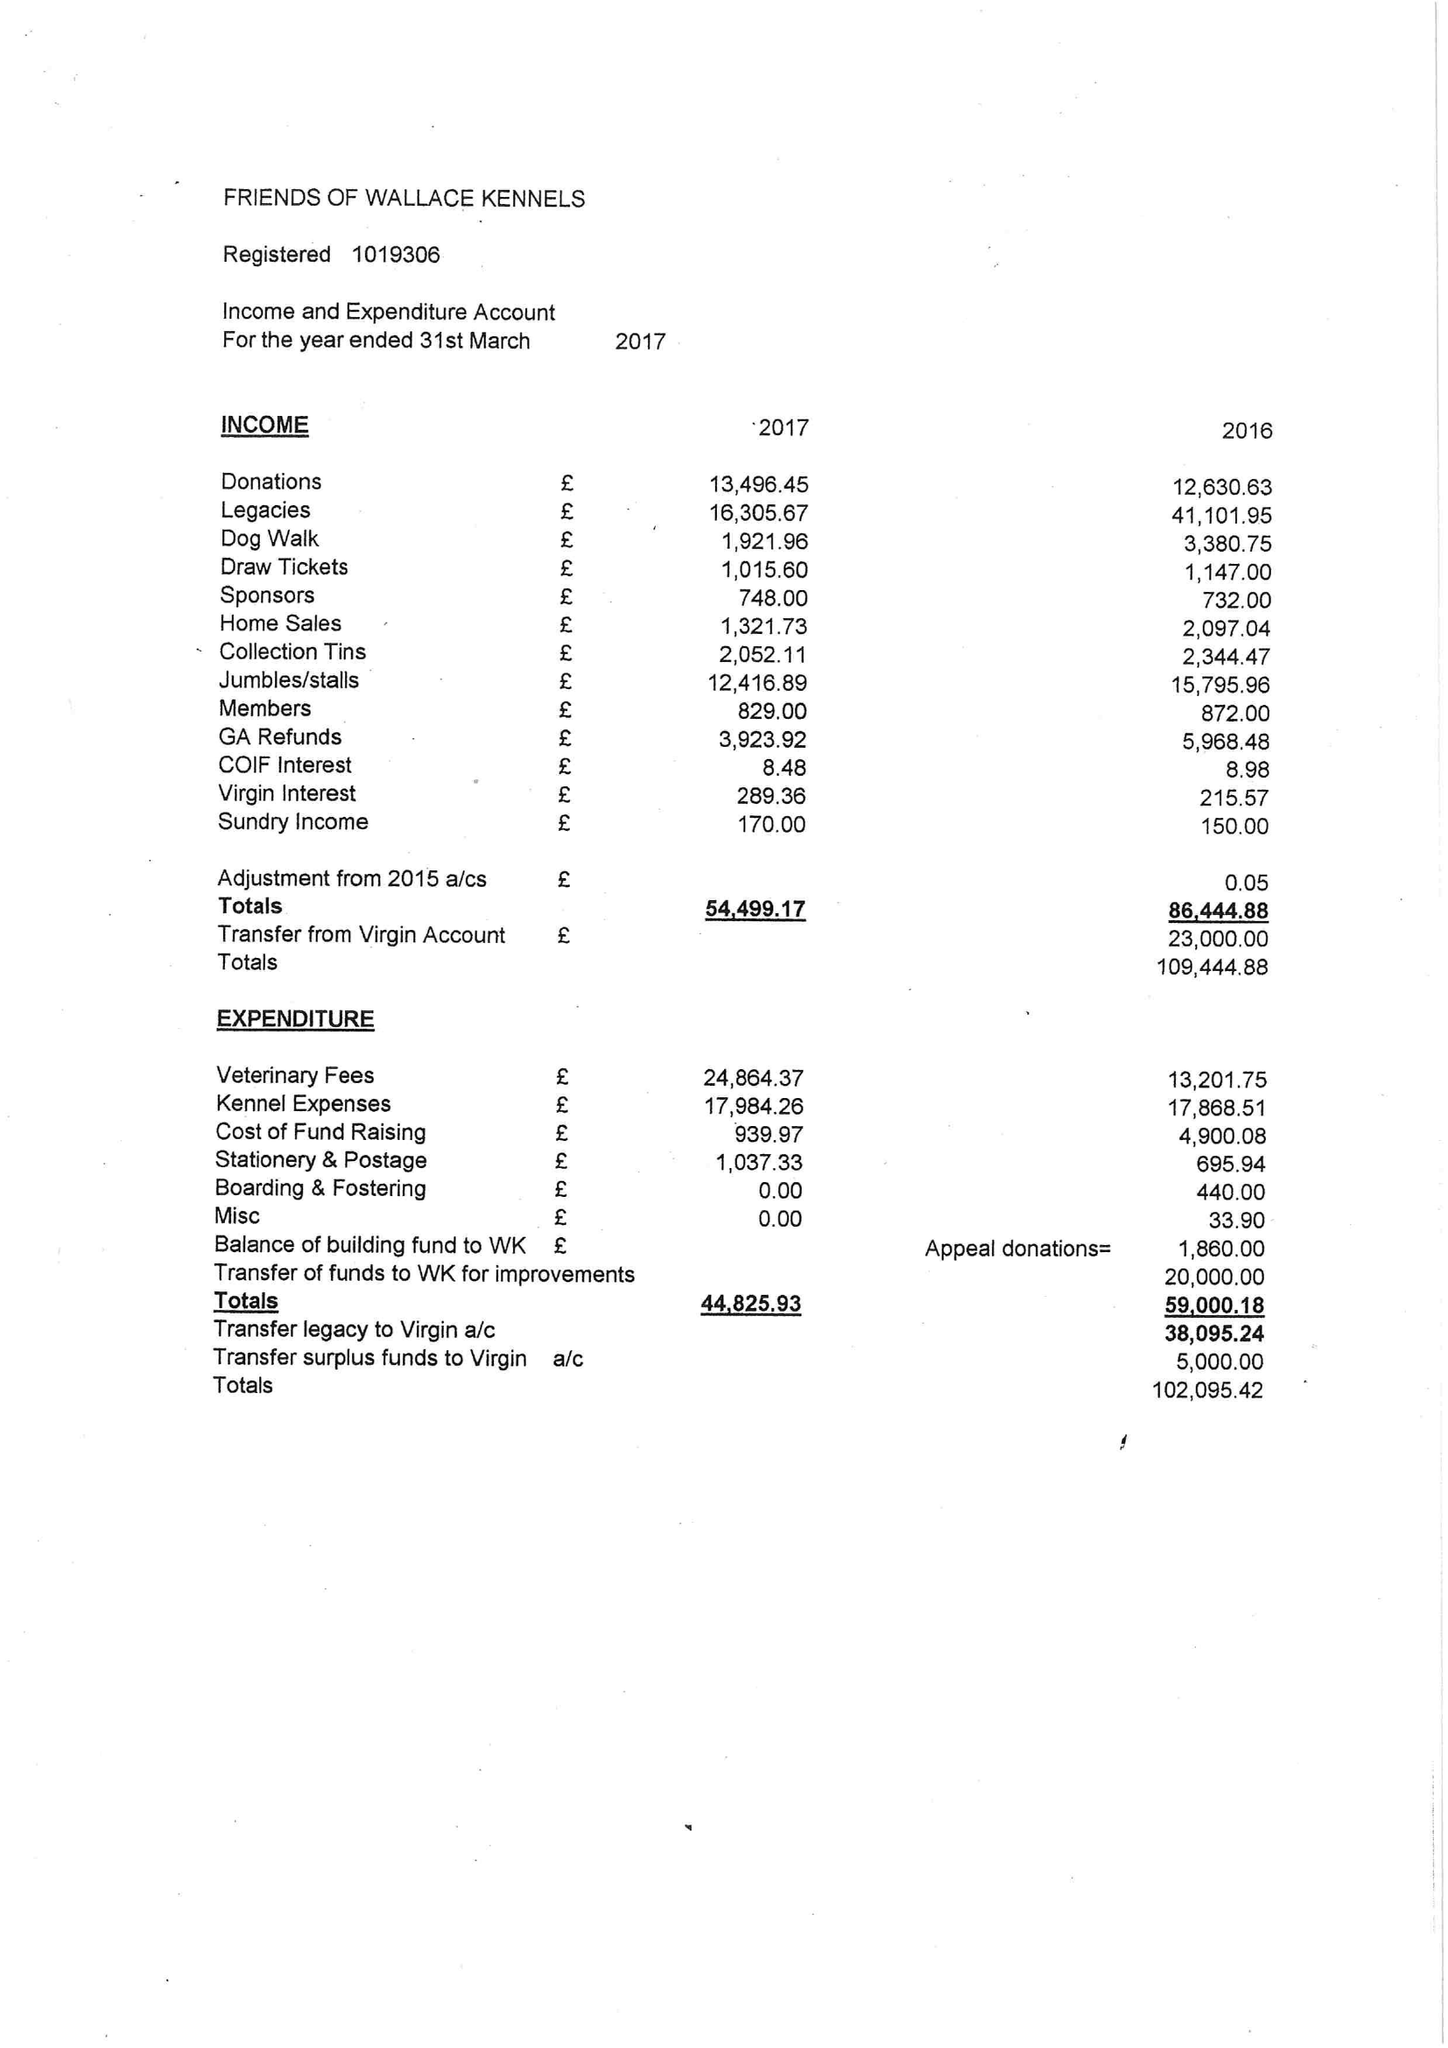What is the value for the charity_name?
Answer the question using a single word or phrase. Friends Of Wallace Kennels 